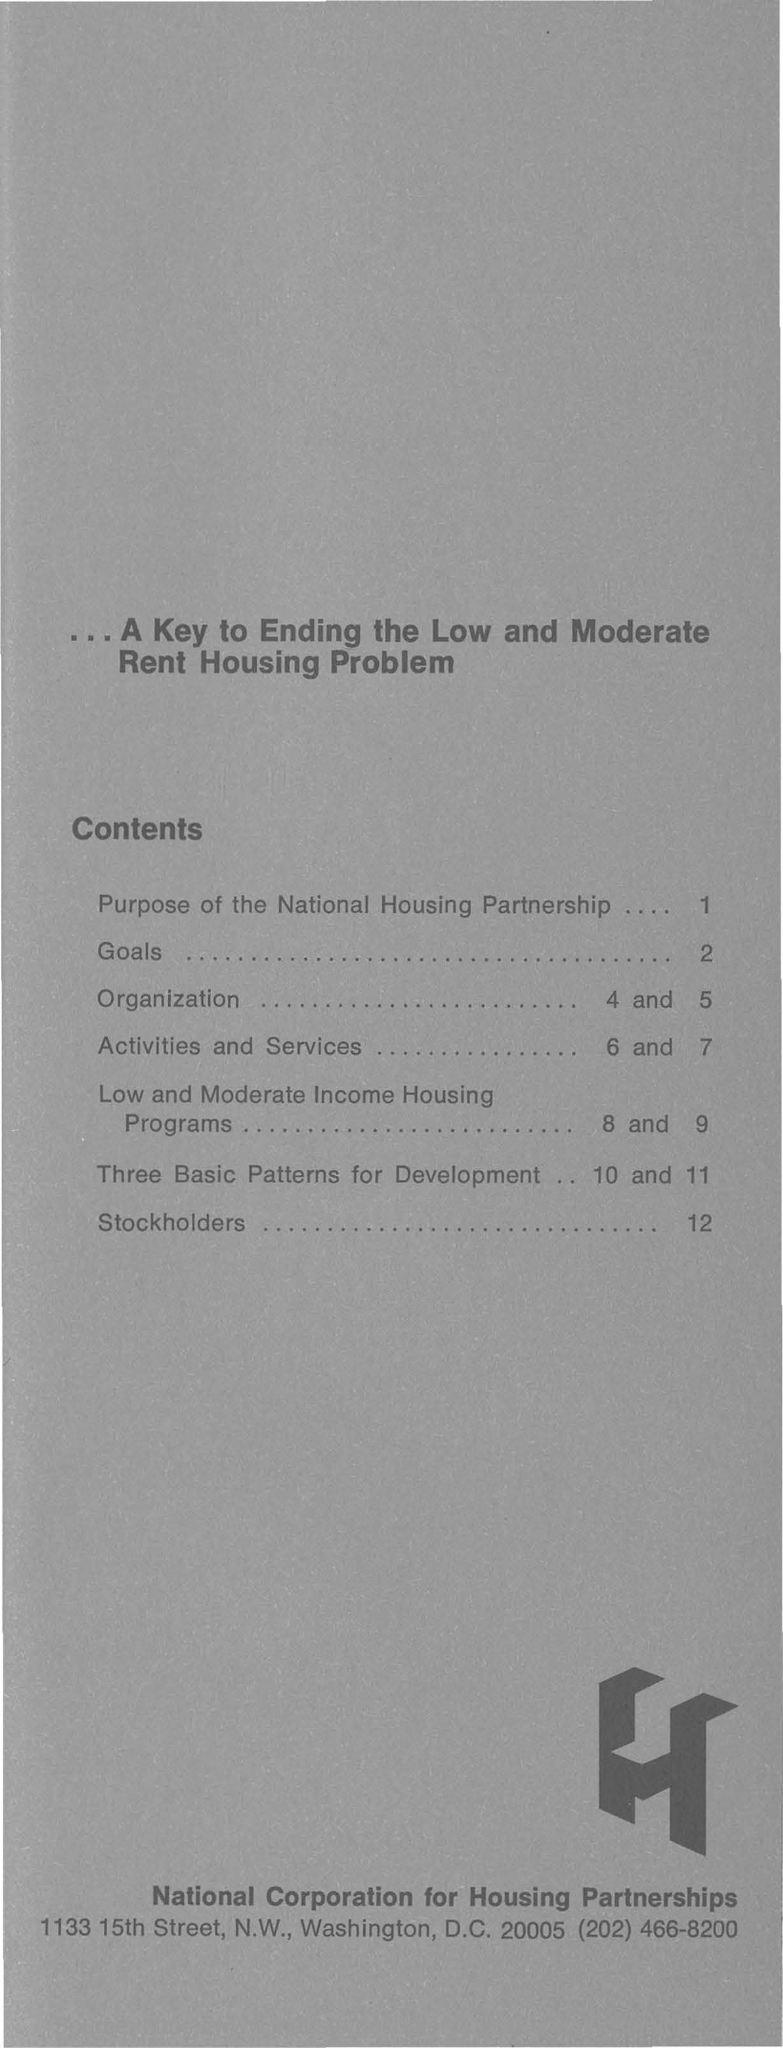Give some essential details in this illustration. The second title in this document is 'Contents.' 